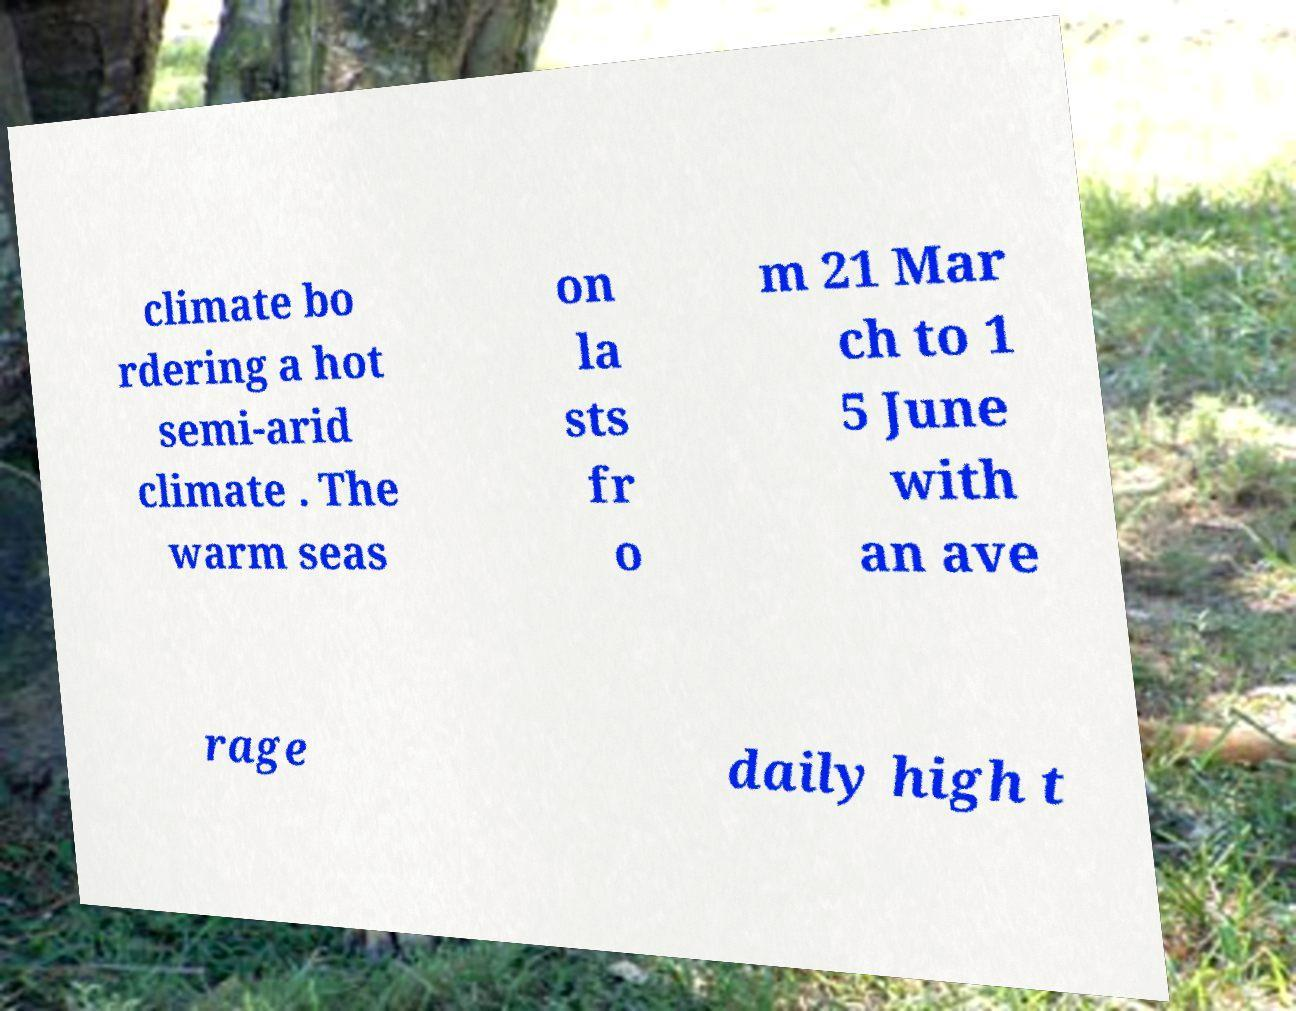Can you accurately transcribe the text from the provided image for me? climate bo rdering a hot semi-arid climate . The warm seas on la sts fr o m 21 Mar ch to 1 5 June with an ave rage daily high t 